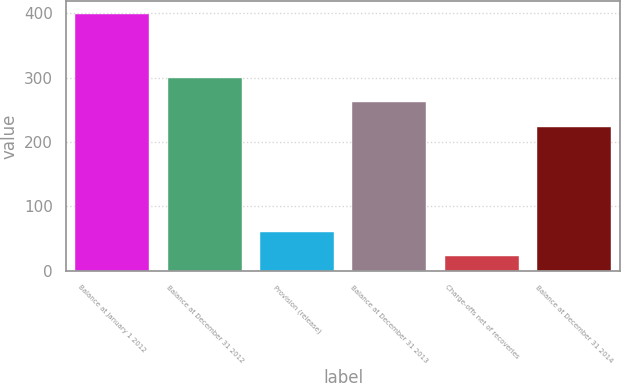Convert chart to OTSL. <chart><loc_0><loc_0><loc_500><loc_500><bar_chart><fcel>Balance at January 1 2012<fcel>Balance at December 31 2012<fcel>Provision (release)<fcel>Balance at December 31 2013<fcel>Charge-offs net of recoveries<fcel>Balance at December 31 2014<nl><fcel>398<fcel>299<fcel>60.5<fcel>261.5<fcel>23<fcel>224<nl></chart> 